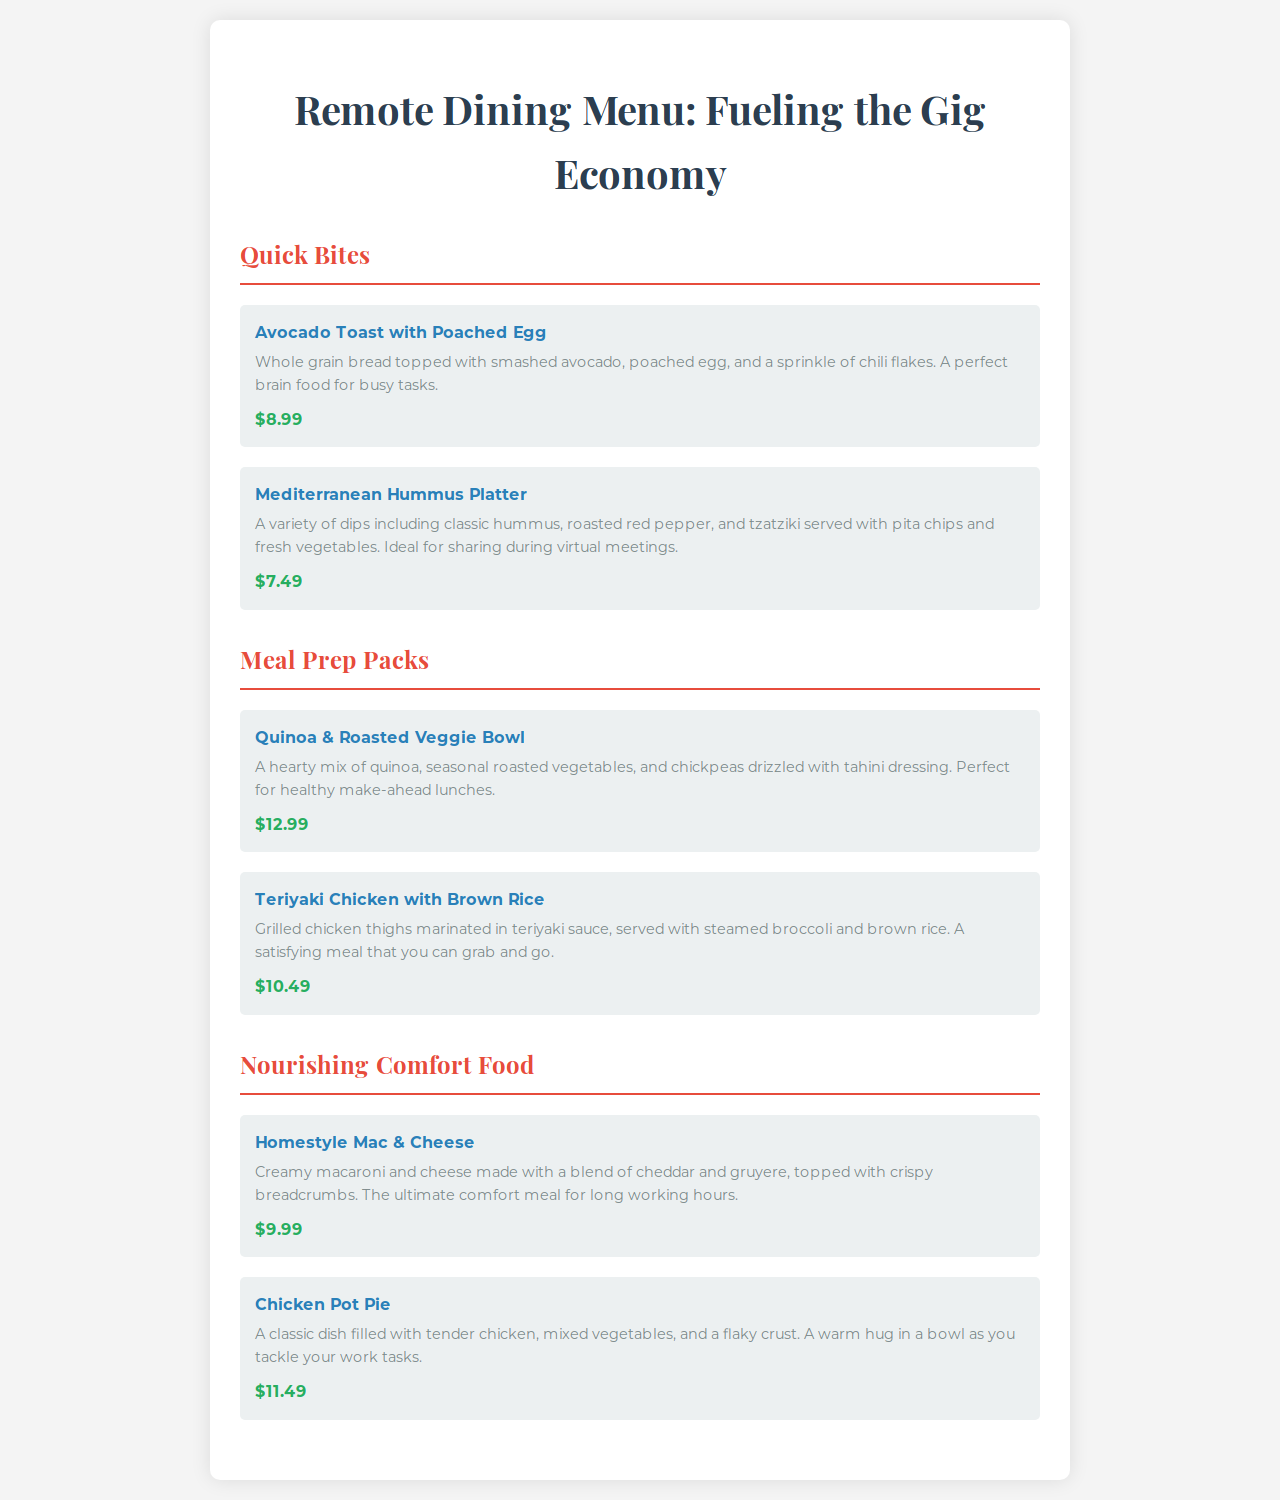what is the title of the menu? The title of the menu is prominently displayed at the top of the document, which indicates its theme and purpose.
Answer: Remote Dining Menu: Fueling the Gig Economy how many sections are in the menu? The document contains three distinct sections that categorize the different types of food offerings.
Answer: 3 what is the price of the Avocado Toast with Poached Egg? The price of each menu item is provided below their descriptions, indicating the cost for that particular item.
Answer: $8.99 which dish is described as "the ultimate comfort meal for long working hours"? The description of comfort food within the menu highlights specific dishes that provide nourishment during work hours.
Answer: Homestyle Mac & Cheese what type of meal is the Teriyaki Chicken with Brown Rice categorized under? The menu categorizes its offerings into sections based on the meals, indicating where each dish belongs.
Answer: Meal Prep Packs which item is ideal for sharing during virtual meetings? Some dishes are specifically noted for their suitability during social or work-related interactions, indicating their intended use.
Answer: Mediterranean Hummus Platter what is included in the Quinoa & Roasted Veggie Bowl? The description of this dish provides details on its components, indicating what to expect when ordered.
Answer: quinoa, seasonal roasted vegetables, chickpeas, tahini dressing how is the Chicken Pot Pie described? The description provides a narrative on the texture and comforting qualities of the dish, appealing to the target audience.
Answer: A warm hug in a bowl as you tackle your work tasks 